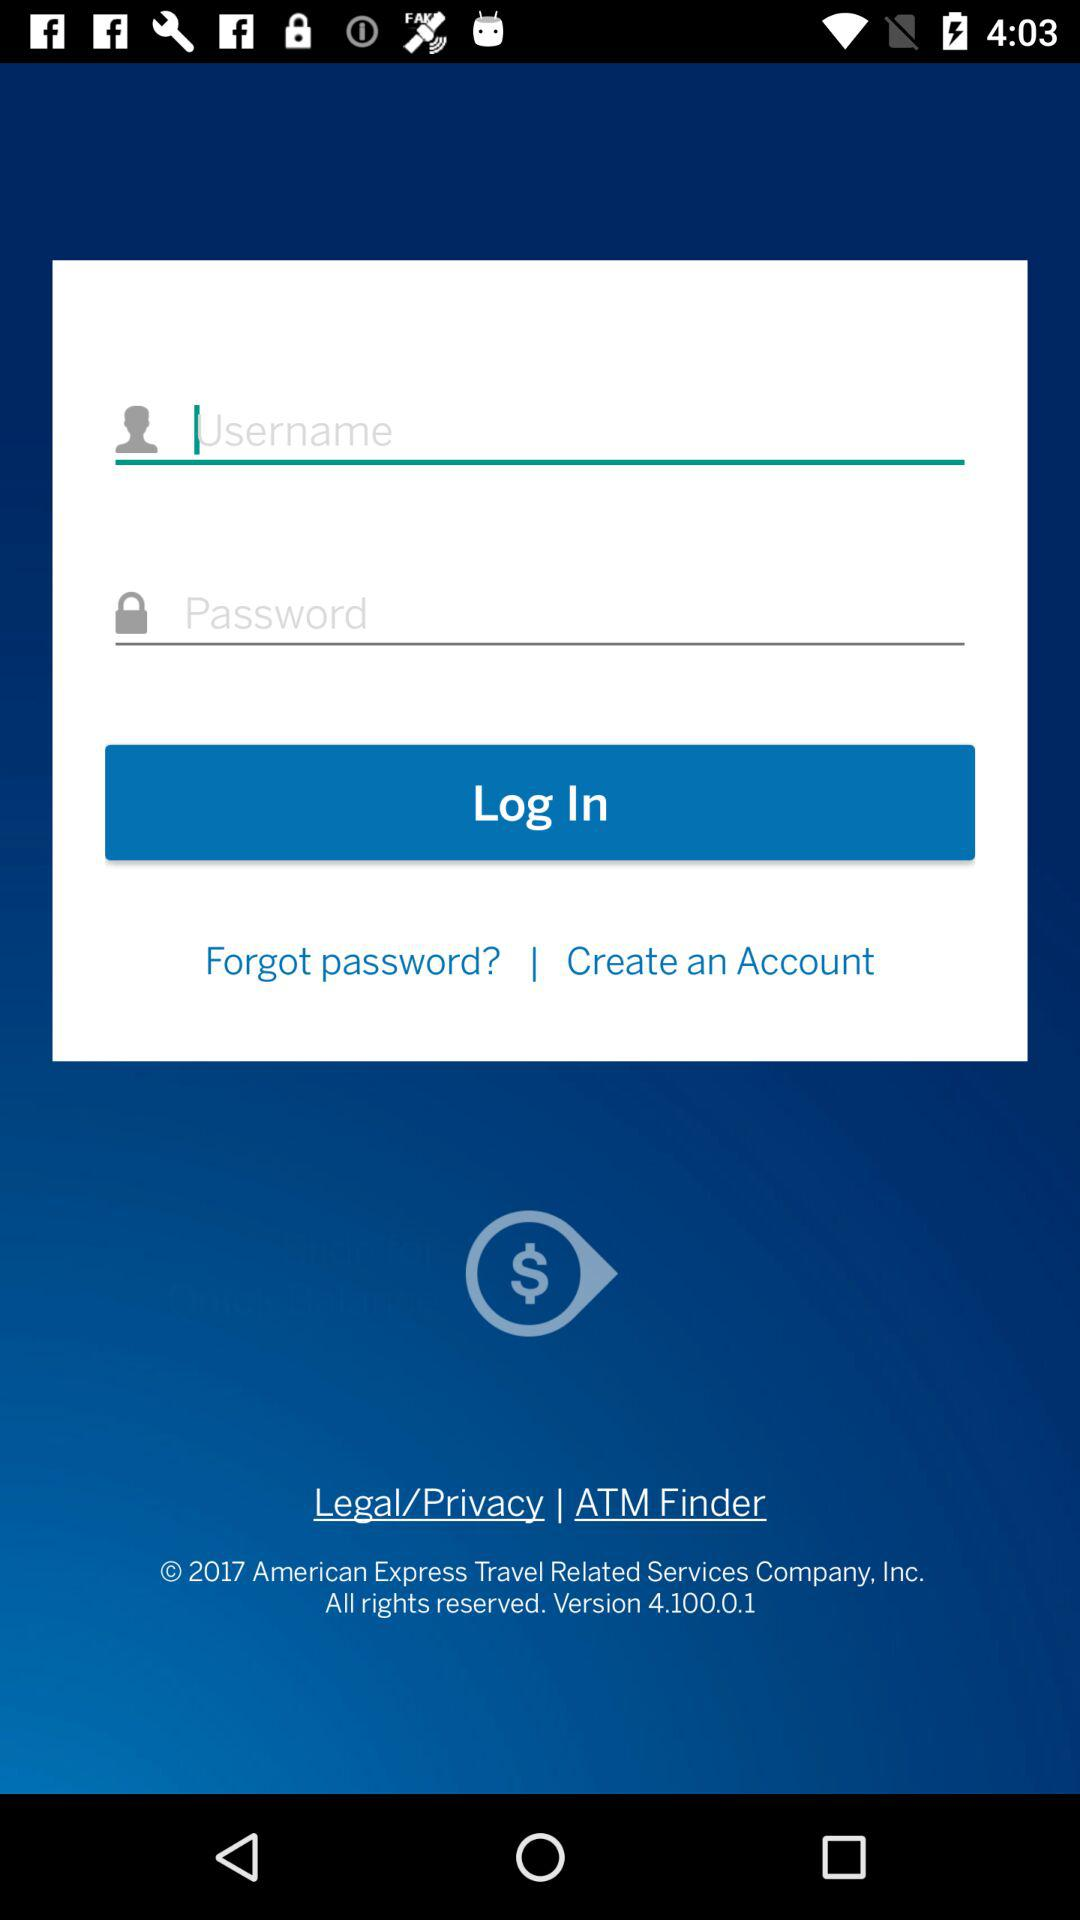Can we reset password?
When the provided information is insufficient, respond with <no answer>. <no answer> 